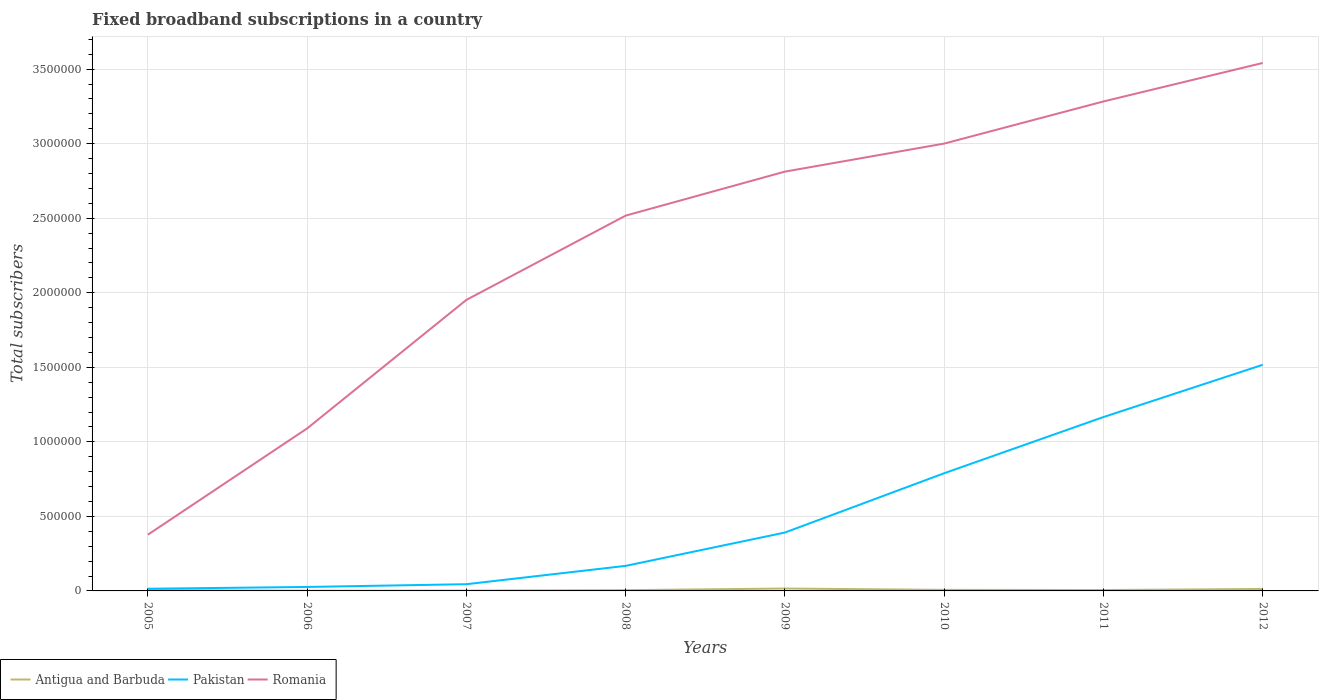Does the line corresponding to Pakistan intersect with the line corresponding to Antigua and Barbuda?
Keep it short and to the point. No. Across all years, what is the maximum number of broadband subscriptions in Antigua and Barbuda?
Your answer should be compact. 1541. In which year was the number of broadband subscriptions in Pakistan maximum?
Make the answer very short. 2005. What is the total number of broadband subscriptions in Pakistan in the graph?
Ensure brevity in your answer.  -1.53e+05. What is the difference between the highest and the second highest number of broadband subscriptions in Pakistan?
Provide a succinct answer. 1.50e+06. What is the difference between the highest and the lowest number of broadband subscriptions in Romania?
Provide a short and direct response. 5. Is the number of broadband subscriptions in Antigua and Barbuda strictly greater than the number of broadband subscriptions in Romania over the years?
Keep it short and to the point. Yes. How many years are there in the graph?
Offer a very short reply. 8. Does the graph contain any zero values?
Keep it short and to the point. No. Does the graph contain grids?
Give a very brief answer. Yes. How many legend labels are there?
Your answer should be compact. 3. What is the title of the graph?
Offer a terse response. Fixed broadband subscriptions in a country. What is the label or title of the X-axis?
Keep it short and to the point. Years. What is the label or title of the Y-axis?
Your answer should be compact. Total subscribers. What is the Total subscribers in Antigua and Barbuda in 2005?
Give a very brief answer. 5801. What is the Total subscribers in Pakistan in 2005?
Your answer should be compact. 1.46e+04. What is the Total subscribers of Romania in 2005?
Your answer should be compact. 3.77e+05. What is the Total subscribers in Antigua and Barbuda in 2006?
Your response must be concise. 1541. What is the Total subscribers of Pakistan in 2006?
Ensure brevity in your answer.  2.66e+04. What is the Total subscribers of Romania in 2006?
Offer a very short reply. 1.09e+06. What is the Total subscribers in Antigua and Barbuda in 2007?
Your response must be concise. 2266. What is the Total subscribers of Pakistan in 2007?
Keep it short and to the point. 4.52e+04. What is the Total subscribers in Romania in 2007?
Ensure brevity in your answer.  1.95e+06. What is the Total subscribers in Antigua and Barbuda in 2008?
Provide a succinct answer. 4986. What is the Total subscribers of Pakistan in 2008?
Make the answer very short. 1.68e+05. What is the Total subscribers in Romania in 2008?
Ensure brevity in your answer.  2.52e+06. What is the Total subscribers in Antigua and Barbuda in 2009?
Your answer should be very brief. 1.60e+04. What is the Total subscribers in Pakistan in 2009?
Provide a succinct answer. 3.92e+05. What is the Total subscribers of Romania in 2009?
Your answer should be compact. 2.81e+06. What is the Total subscribers in Antigua and Barbuda in 2010?
Provide a short and direct response. 7119. What is the Total subscribers of Pakistan in 2010?
Offer a terse response. 7.89e+05. What is the Total subscribers in Romania in 2010?
Provide a succinct answer. 3.00e+06. What is the Total subscribers in Antigua and Barbuda in 2011?
Offer a very short reply. 6000. What is the Total subscribers in Pakistan in 2011?
Ensure brevity in your answer.  1.17e+06. What is the Total subscribers in Romania in 2011?
Keep it short and to the point. 3.28e+06. What is the Total subscribers of Antigua and Barbuda in 2012?
Offer a terse response. 1.31e+04. What is the Total subscribers of Pakistan in 2012?
Give a very brief answer. 1.52e+06. What is the Total subscribers of Romania in 2012?
Offer a very short reply. 3.54e+06. Across all years, what is the maximum Total subscribers in Antigua and Barbuda?
Your answer should be compact. 1.60e+04. Across all years, what is the maximum Total subscribers in Pakistan?
Your answer should be very brief. 1.52e+06. Across all years, what is the maximum Total subscribers in Romania?
Make the answer very short. 3.54e+06. Across all years, what is the minimum Total subscribers in Antigua and Barbuda?
Ensure brevity in your answer.  1541. Across all years, what is the minimum Total subscribers of Pakistan?
Your response must be concise. 1.46e+04. Across all years, what is the minimum Total subscribers in Romania?
Offer a very short reply. 3.77e+05. What is the total Total subscribers of Antigua and Barbuda in the graph?
Offer a terse response. 5.68e+04. What is the total Total subscribers in Pakistan in the graph?
Your answer should be very brief. 4.12e+06. What is the total Total subscribers in Romania in the graph?
Ensure brevity in your answer.  1.86e+07. What is the difference between the Total subscribers in Antigua and Barbuda in 2005 and that in 2006?
Offer a terse response. 4260. What is the difference between the Total subscribers in Pakistan in 2005 and that in 2006?
Make the answer very short. -1.20e+04. What is the difference between the Total subscribers of Romania in 2005 and that in 2006?
Provide a short and direct response. -7.13e+05. What is the difference between the Total subscribers in Antigua and Barbuda in 2005 and that in 2007?
Your answer should be very brief. 3535. What is the difference between the Total subscribers of Pakistan in 2005 and that in 2007?
Offer a very short reply. -3.06e+04. What is the difference between the Total subscribers in Romania in 2005 and that in 2007?
Your response must be concise. -1.58e+06. What is the difference between the Total subscribers in Antigua and Barbuda in 2005 and that in 2008?
Your answer should be compact. 815. What is the difference between the Total subscribers in Pakistan in 2005 and that in 2008?
Your answer should be compact. -1.53e+05. What is the difference between the Total subscribers of Romania in 2005 and that in 2008?
Offer a very short reply. -2.14e+06. What is the difference between the Total subscribers in Antigua and Barbuda in 2005 and that in 2009?
Offer a very short reply. -1.02e+04. What is the difference between the Total subscribers of Pakistan in 2005 and that in 2009?
Make the answer very short. -3.77e+05. What is the difference between the Total subscribers in Romania in 2005 and that in 2009?
Keep it short and to the point. -2.44e+06. What is the difference between the Total subscribers in Antigua and Barbuda in 2005 and that in 2010?
Your answer should be very brief. -1318. What is the difference between the Total subscribers of Pakistan in 2005 and that in 2010?
Your answer should be very brief. -7.75e+05. What is the difference between the Total subscribers in Romania in 2005 and that in 2010?
Keep it short and to the point. -2.62e+06. What is the difference between the Total subscribers in Antigua and Barbuda in 2005 and that in 2011?
Provide a succinct answer. -199. What is the difference between the Total subscribers in Pakistan in 2005 and that in 2011?
Your answer should be very brief. -1.15e+06. What is the difference between the Total subscribers of Romania in 2005 and that in 2011?
Your answer should be very brief. -2.91e+06. What is the difference between the Total subscribers of Antigua and Barbuda in 2005 and that in 2012?
Ensure brevity in your answer.  -7269. What is the difference between the Total subscribers of Pakistan in 2005 and that in 2012?
Provide a succinct answer. -1.50e+06. What is the difference between the Total subscribers of Romania in 2005 and that in 2012?
Make the answer very short. -3.16e+06. What is the difference between the Total subscribers in Antigua and Barbuda in 2006 and that in 2007?
Make the answer very short. -725. What is the difference between the Total subscribers of Pakistan in 2006 and that in 2007?
Provide a succinct answer. -1.85e+04. What is the difference between the Total subscribers in Romania in 2006 and that in 2007?
Provide a succinct answer. -8.62e+05. What is the difference between the Total subscribers of Antigua and Barbuda in 2006 and that in 2008?
Give a very brief answer. -3445. What is the difference between the Total subscribers of Pakistan in 2006 and that in 2008?
Provide a short and direct response. -1.41e+05. What is the difference between the Total subscribers in Romania in 2006 and that in 2008?
Offer a very short reply. -1.43e+06. What is the difference between the Total subscribers of Antigua and Barbuda in 2006 and that in 2009?
Keep it short and to the point. -1.45e+04. What is the difference between the Total subscribers of Pakistan in 2006 and that in 2009?
Your answer should be compact. -3.65e+05. What is the difference between the Total subscribers in Romania in 2006 and that in 2009?
Keep it short and to the point. -1.72e+06. What is the difference between the Total subscribers in Antigua and Barbuda in 2006 and that in 2010?
Offer a very short reply. -5578. What is the difference between the Total subscribers in Pakistan in 2006 and that in 2010?
Make the answer very short. -7.63e+05. What is the difference between the Total subscribers of Romania in 2006 and that in 2010?
Give a very brief answer. -1.91e+06. What is the difference between the Total subscribers in Antigua and Barbuda in 2006 and that in 2011?
Your answer should be compact. -4459. What is the difference between the Total subscribers in Pakistan in 2006 and that in 2011?
Give a very brief answer. -1.14e+06. What is the difference between the Total subscribers in Romania in 2006 and that in 2011?
Make the answer very short. -2.19e+06. What is the difference between the Total subscribers in Antigua and Barbuda in 2006 and that in 2012?
Offer a very short reply. -1.15e+04. What is the difference between the Total subscribers of Pakistan in 2006 and that in 2012?
Offer a very short reply. -1.49e+06. What is the difference between the Total subscribers in Romania in 2006 and that in 2012?
Your answer should be compact. -2.45e+06. What is the difference between the Total subscribers in Antigua and Barbuda in 2007 and that in 2008?
Provide a succinct answer. -2720. What is the difference between the Total subscribers in Pakistan in 2007 and that in 2008?
Offer a terse response. -1.23e+05. What is the difference between the Total subscribers of Romania in 2007 and that in 2008?
Give a very brief answer. -5.65e+05. What is the difference between the Total subscribers in Antigua and Barbuda in 2007 and that in 2009?
Make the answer very short. -1.37e+04. What is the difference between the Total subscribers of Pakistan in 2007 and that in 2009?
Provide a succinct answer. -3.46e+05. What is the difference between the Total subscribers of Romania in 2007 and that in 2009?
Ensure brevity in your answer.  -8.60e+05. What is the difference between the Total subscribers in Antigua and Barbuda in 2007 and that in 2010?
Your answer should be very brief. -4853. What is the difference between the Total subscribers in Pakistan in 2007 and that in 2010?
Your answer should be compact. -7.44e+05. What is the difference between the Total subscribers in Romania in 2007 and that in 2010?
Provide a short and direct response. -1.05e+06. What is the difference between the Total subscribers of Antigua and Barbuda in 2007 and that in 2011?
Your response must be concise. -3734. What is the difference between the Total subscribers of Pakistan in 2007 and that in 2011?
Offer a terse response. -1.12e+06. What is the difference between the Total subscribers of Romania in 2007 and that in 2011?
Provide a succinct answer. -1.33e+06. What is the difference between the Total subscribers in Antigua and Barbuda in 2007 and that in 2012?
Your answer should be compact. -1.08e+04. What is the difference between the Total subscribers in Pakistan in 2007 and that in 2012?
Offer a very short reply. -1.47e+06. What is the difference between the Total subscribers of Romania in 2007 and that in 2012?
Offer a terse response. -1.59e+06. What is the difference between the Total subscribers of Antigua and Barbuda in 2008 and that in 2009?
Make the answer very short. -1.10e+04. What is the difference between the Total subscribers in Pakistan in 2008 and that in 2009?
Your response must be concise. -2.24e+05. What is the difference between the Total subscribers in Romania in 2008 and that in 2009?
Give a very brief answer. -2.95e+05. What is the difference between the Total subscribers in Antigua and Barbuda in 2008 and that in 2010?
Offer a terse response. -2133. What is the difference between the Total subscribers in Pakistan in 2008 and that in 2010?
Offer a terse response. -6.21e+05. What is the difference between the Total subscribers in Romania in 2008 and that in 2010?
Your response must be concise. -4.83e+05. What is the difference between the Total subscribers of Antigua and Barbuda in 2008 and that in 2011?
Your answer should be very brief. -1014. What is the difference between the Total subscribers of Pakistan in 2008 and that in 2011?
Give a very brief answer. -9.98e+05. What is the difference between the Total subscribers in Romania in 2008 and that in 2011?
Provide a succinct answer. -7.66e+05. What is the difference between the Total subscribers in Antigua and Barbuda in 2008 and that in 2012?
Provide a short and direct response. -8084. What is the difference between the Total subscribers of Pakistan in 2008 and that in 2012?
Give a very brief answer. -1.35e+06. What is the difference between the Total subscribers in Romania in 2008 and that in 2012?
Your response must be concise. -1.02e+06. What is the difference between the Total subscribers of Antigua and Barbuda in 2009 and that in 2010?
Provide a succinct answer. 8895. What is the difference between the Total subscribers of Pakistan in 2009 and that in 2010?
Offer a terse response. -3.98e+05. What is the difference between the Total subscribers of Romania in 2009 and that in 2010?
Make the answer very short. -1.88e+05. What is the difference between the Total subscribers of Antigua and Barbuda in 2009 and that in 2011?
Your response must be concise. 1.00e+04. What is the difference between the Total subscribers in Pakistan in 2009 and that in 2011?
Your response must be concise. -7.75e+05. What is the difference between the Total subscribers of Romania in 2009 and that in 2011?
Your answer should be very brief. -4.71e+05. What is the difference between the Total subscribers of Antigua and Barbuda in 2009 and that in 2012?
Offer a very short reply. 2944. What is the difference between the Total subscribers of Pakistan in 2009 and that in 2012?
Keep it short and to the point. -1.13e+06. What is the difference between the Total subscribers of Romania in 2009 and that in 2012?
Provide a short and direct response. -7.29e+05. What is the difference between the Total subscribers in Antigua and Barbuda in 2010 and that in 2011?
Your answer should be compact. 1119. What is the difference between the Total subscribers of Pakistan in 2010 and that in 2011?
Offer a terse response. -3.77e+05. What is the difference between the Total subscribers in Romania in 2010 and that in 2011?
Keep it short and to the point. -2.83e+05. What is the difference between the Total subscribers of Antigua and Barbuda in 2010 and that in 2012?
Your answer should be compact. -5951. What is the difference between the Total subscribers in Pakistan in 2010 and that in 2012?
Provide a short and direct response. -7.27e+05. What is the difference between the Total subscribers of Romania in 2010 and that in 2012?
Ensure brevity in your answer.  -5.41e+05. What is the difference between the Total subscribers in Antigua and Barbuda in 2011 and that in 2012?
Offer a terse response. -7070. What is the difference between the Total subscribers of Pakistan in 2011 and that in 2012?
Provide a succinct answer. -3.51e+05. What is the difference between the Total subscribers of Romania in 2011 and that in 2012?
Give a very brief answer. -2.58e+05. What is the difference between the Total subscribers of Antigua and Barbuda in 2005 and the Total subscribers of Pakistan in 2006?
Your answer should be compact. -2.08e+04. What is the difference between the Total subscribers of Antigua and Barbuda in 2005 and the Total subscribers of Romania in 2006?
Your answer should be very brief. -1.08e+06. What is the difference between the Total subscribers of Pakistan in 2005 and the Total subscribers of Romania in 2006?
Offer a very short reply. -1.08e+06. What is the difference between the Total subscribers in Antigua and Barbuda in 2005 and the Total subscribers in Pakistan in 2007?
Ensure brevity in your answer.  -3.94e+04. What is the difference between the Total subscribers in Antigua and Barbuda in 2005 and the Total subscribers in Romania in 2007?
Give a very brief answer. -1.95e+06. What is the difference between the Total subscribers of Pakistan in 2005 and the Total subscribers of Romania in 2007?
Your answer should be very brief. -1.94e+06. What is the difference between the Total subscribers in Antigua and Barbuda in 2005 and the Total subscribers in Pakistan in 2008?
Provide a short and direct response. -1.62e+05. What is the difference between the Total subscribers in Antigua and Barbuda in 2005 and the Total subscribers in Romania in 2008?
Give a very brief answer. -2.51e+06. What is the difference between the Total subscribers of Pakistan in 2005 and the Total subscribers of Romania in 2008?
Offer a very short reply. -2.50e+06. What is the difference between the Total subscribers of Antigua and Barbuda in 2005 and the Total subscribers of Pakistan in 2009?
Ensure brevity in your answer.  -3.86e+05. What is the difference between the Total subscribers in Antigua and Barbuda in 2005 and the Total subscribers in Romania in 2009?
Provide a short and direct response. -2.81e+06. What is the difference between the Total subscribers of Pakistan in 2005 and the Total subscribers of Romania in 2009?
Offer a terse response. -2.80e+06. What is the difference between the Total subscribers in Antigua and Barbuda in 2005 and the Total subscribers in Pakistan in 2010?
Keep it short and to the point. -7.84e+05. What is the difference between the Total subscribers in Antigua and Barbuda in 2005 and the Total subscribers in Romania in 2010?
Keep it short and to the point. -2.99e+06. What is the difference between the Total subscribers in Pakistan in 2005 and the Total subscribers in Romania in 2010?
Your answer should be very brief. -2.99e+06. What is the difference between the Total subscribers in Antigua and Barbuda in 2005 and the Total subscribers in Pakistan in 2011?
Offer a terse response. -1.16e+06. What is the difference between the Total subscribers of Antigua and Barbuda in 2005 and the Total subscribers of Romania in 2011?
Your answer should be compact. -3.28e+06. What is the difference between the Total subscribers in Pakistan in 2005 and the Total subscribers in Romania in 2011?
Your answer should be compact. -3.27e+06. What is the difference between the Total subscribers in Antigua and Barbuda in 2005 and the Total subscribers in Pakistan in 2012?
Provide a short and direct response. -1.51e+06. What is the difference between the Total subscribers of Antigua and Barbuda in 2005 and the Total subscribers of Romania in 2012?
Offer a terse response. -3.54e+06. What is the difference between the Total subscribers in Pakistan in 2005 and the Total subscribers in Romania in 2012?
Offer a terse response. -3.53e+06. What is the difference between the Total subscribers of Antigua and Barbuda in 2006 and the Total subscribers of Pakistan in 2007?
Your response must be concise. -4.36e+04. What is the difference between the Total subscribers in Antigua and Barbuda in 2006 and the Total subscribers in Romania in 2007?
Make the answer very short. -1.95e+06. What is the difference between the Total subscribers in Pakistan in 2006 and the Total subscribers in Romania in 2007?
Your answer should be very brief. -1.93e+06. What is the difference between the Total subscribers of Antigua and Barbuda in 2006 and the Total subscribers of Pakistan in 2008?
Your answer should be very brief. -1.67e+05. What is the difference between the Total subscribers of Antigua and Barbuda in 2006 and the Total subscribers of Romania in 2008?
Give a very brief answer. -2.52e+06. What is the difference between the Total subscribers in Pakistan in 2006 and the Total subscribers in Romania in 2008?
Provide a succinct answer. -2.49e+06. What is the difference between the Total subscribers of Antigua and Barbuda in 2006 and the Total subscribers of Pakistan in 2009?
Ensure brevity in your answer.  -3.90e+05. What is the difference between the Total subscribers of Antigua and Barbuda in 2006 and the Total subscribers of Romania in 2009?
Your answer should be very brief. -2.81e+06. What is the difference between the Total subscribers of Pakistan in 2006 and the Total subscribers of Romania in 2009?
Give a very brief answer. -2.79e+06. What is the difference between the Total subscribers of Antigua and Barbuda in 2006 and the Total subscribers of Pakistan in 2010?
Provide a succinct answer. -7.88e+05. What is the difference between the Total subscribers of Antigua and Barbuda in 2006 and the Total subscribers of Romania in 2010?
Give a very brief answer. -3.00e+06. What is the difference between the Total subscribers in Pakistan in 2006 and the Total subscribers in Romania in 2010?
Provide a short and direct response. -2.97e+06. What is the difference between the Total subscribers of Antigua and Barbuda in 2006 and the Total subscribers of Pakistan in 2011?
Provide a short and direct response. -1.16e+06. What is the difference between the Total subscribers in Antigua and Barbuda in 2006 and the Total subscribers in Romania in 2011?
Your answer should be compact. -3.28e+06. What is the difference between the Total subscribers of Pakistan in 2006 and the Total subscribers of Romania in 2011?
Your answer should be very brief. -3.26e+06. What is the difference between the Total subscribers of Antigua and Barbuda in 2006 and the Total subscribers of Pakistan in 2012?
Your answer should be compact. -1.52e+06. What is the difference between the Total subscribers in Antigua and Barbuda in 2006 and the Total subscribers in Romania in 2012?
Keep it short and to the point. -3.54e+06. What is the difference between the Total subscribers in Pakistan in 2006 and the Total subscribers in Romania in 2012?
Provide a succinct answer. -3.51e+06. What is the difference between the Total subscribers of Antigua and Barbuda in 2007 and the Total subscribers of Pakistan in 2008?
Provide a short and direct response. -1.66e+05. What is the difference between the Total subscribers in Antigua and Barbuda in 2007 and the Total subscribers in Romania in 2008?
Offer a terse response. -2.52e+06. What is the difference between the Total subscribers of Pakistan in 2007 and the Total subscribers of Romania in 2008?
Offer a very short reply. -2.47e+06. What is the difference between the Total subscribers of Antigua and Barbuda in 2007 and the Total subscribers of Pakistan in 2009?
Keep it short and to the point. -3.89e+05. What is the difference between the Total subscribers in Antigua and Barbuda in 2007 and the Total subscribers in Romania in 2009?
Your response must be concise. -2.81e+06. What is the difference between the Total subscribers of Pakistan in 2007 and the Total subscribers of Romania in 2009?
Give a very brief answer. -2.77e+06. What is the difference between the Total subscribers in Antigua and Barbuda in 2007 and the Total subscribers in Pakistan in 2010?
Keep it short and to the point. -7.87e+05. What is the difference between the Total subscribers of Antigua and Barbuda in 2007 and the Total subscribers of Romania in 2010?
Make the answer very short. -3.00e+06. What is the difference between the Total subscribers in Pakistan in 2007 and the Total subscribers in Romania in 2010?
Your answer should be compact. -2.96e+06. What is the difference between the Total subscribers in Antigua and Barbuda in 2007 and the Total subscribers in Pakistan in 2011?
Provide a succinct answer. -1.16e+06. What is the difference between the Total subscribers of Antigua and Barbuda in 2007 and the Total subscribers of Romania in 2011?
Keep it short and to the point. -3.28e+06. What is the difference between the Total subscribers in Pakistan in 2007 and the Total subscribers in Romania in 2011?
Provide a succinct answer. -3.24e+06. What is the difference between the Total subscribers in Antigua and Barbuda in 2007 and the Total subscribers in Pakistan in 2012?
Provide a short and direct response. -1.51e+06. What is the difference between the Total subscribers in Antigua and Barbuda in 2007 and the Total subscribers in Romania in 2012?
Keep it short and to the point. -3.54e+06. What is the difference between the Total subscribers of Pakistan in 2007 and the Total subscribers of Romania in 2012?
Your response must be concise. -3.50e+06. What is the difference between the Total subscribers in Antigua and Barbuda in 2008 and the Total subscribers in Pakistan in 2009?
Give a very brief answer. -3.87e+05. What is the difference between the Total subscribers in Antigua and Barbuda in 2008 and the Total subscribers in Romania in 2009?
Ensure brevity in your answer.  -2.81e+06. What is the difference between the Total subscribers of Pakistan in 2008 and the Total subscribers of Romania in 2009?
Offer a very short reply. -2.64e+06. What is the difference between the Total subscribers of Antigua and Barbuda in 2008 and the Total subscribers of Pakistan in 2010?
Your response must be concise. -7.85e+05. What is the difference between the Total subscribers in Antigua and Barbuda in 2008 and the Total subscribers in Romania in 2010?
Your answer should be very brief. -3.00e+06. What is the difference between the Total subscribers in Pakistan in 2008 and the Total subscribers in Romania in 2010?
Ensure brevity in your answer.  -2.83e+06. What is the difference between the Total subscribers in Antigua and Barbuda in 2008 and the Total subscribers in Pakistan in 2011?
Offer a terse response. -1.16e+06. What is the difference between the Total subscribers in Antigua and Barbuda in 2008 and the Total subscribers in Romania in 2011?
Offer a terse response. -3.28e+06. What is the difference between the Total subscribers of Pakistan in 2008 and the Total subscribers of Romania in 2011?
Make the answer very short. -3.12e+06. What is the difference between the Total subscribers in Antigua and Barbuda in 2008 and the Total subscribers in Pakistan in 2012?
Your response must be concise. -1.51e+06. What is the difference between the Total subscribers in Antigua and Barbuda in 2008 and the Total subscribers in Romania in 2012?
Offer a terse response. -3.54e+06. What is the difference between the Total subscribers in Pakistan in 2008 and the Total subscribers in Romania in 2012?
Your answer should be compact. -3.37e+06. What is the difference between the Total subscribers in Antigua and Barbuda in 2009 and the Total subscribers in Pakistan in 2010?
Your answer should be compact. -7.73e+05. What is the difference between the Total subscribers of Antigua and Barbuda in 2009 and the Total subscribers of Romania in 2010?
Provide a succinct answer. -2.98e+06. What is the difference between the Total subscribers of Pakistan in 2009 and the Total subscribers of Romania in 2010?
Give a very brief answer. -2.61e+06. What is the difference between the Total subscribers in Antigua and Barbuda in 2009 and the Total subscribers in Pakistan in 2011?
Offer a very short reply. -1.15e+06. What is the difference between the Total subscribers of Antigua and Barbuda in 2009 and the Total subscribers of Romania in 2011?
Provide a short and direct response. -3.27e+06. What is the difference between the Total subscribers in Pakistan in 2009 and the Total subscribers in Romania in 2011?
Your answer should be compact. -2.89e+06. What is the difference between the Total subscribers of Antigua and Barbuda in 2009 and the Total subscribers of Pakistan in 2012?
Your response must be concise. -1.50e+06. What is the difference between the Total subscribers of Antigua and Barbuda in 2009 and the Total subscribers of Romania in 2012?
Your response must be concise. -3.53e+06. What is the difference between the Total subscribers in Pakistan in 2009 and the Total subscribers in Romania in 2012?
Your answer should be compact. -3.15e+06. What is the difference between the Total subscribers of Antigua and Barbuda in 2010 and the Total subscribers of Pakistan in 2011?
Your answer should be compact. -1.16e+06. What is the difference between the Total subscribers in Antigua and Barbuda in 2010 and the Total subscribers in Romania in 2011?
Provide a succinct answer. -3.28e+06. What is the difference between the Total subscribers in Pakistan in 2010 and the Total subscribers in Romania in 2011?
Your response must be concise. -2.49e+06. What is the difference between the Total subscribers of Antigua and Barbuda in 2010 and the Total subscribers of Pakistan in 2012?
Provide a succinct answer. -1.51e+06. What is the difference between the Total subscribers in Antigua and Barbuda in 2010 and the Total subscribers in Romania in 2012?
Give a very brief answer. -3.53e+06. What is the difference between the Total subscribers of Pakistan in 2010 and the Total subscribers of Romania in 2012?
Provide a succinct answer. -2.75e+06. What is the difference between the Total subscribers of Antigua and Barbuda in 2011 and the Total subscribers of Pakistan in 2012?
Your answer should be very brief. -1.51e+06. What is the difference between the Total subscribers of Antigua and Barbuda in 2011 and the Total subscribers of Romania in 2012?
Keep it short and to the point. -3.54e+06. What is the difference between the Total subscribers in Pakistan in 2011 and the Total subscribers in Romania in 2012?
Your answer should be compact. -2.38e+06. What is the average Total subscribers in Antigua and Barbuda per year?
Provide a short and direct response. 7099.62. What is the average Total subscribers in Pakistan per year?
Give a very brief answer. 5.15e+05. What is the average Total subscribers in Romania per year?
Give a very brief answer. 2.32e+06. In the year 2005, what is the difference between the Total subscribers in Antigua and Barbuda and Total subscribers in Pakistan?
Provide a succinct answer. -8799. In the year 2005, what is the difference between the Total subscribers of Antigua and Barbuda and Total subscribers of Romania?
Provide a succinct answer. -3.71e+05. In the year 2005, what is the difference between the Total subscribers of Pakistan and Total subscribers of Romania?
Ensure brevity in your answer.  -3.62e+05. In the year 2006, what is the difference between the Total subscribers in Antigua and Barbuda and Total subscribers in Pakistan?
Your answer should be compact. -2.51e+04. In the year 2006, what is the difference between the Total subscribers of Antigua and Barbuda and Total subscribers of Romania?
Make the answer very short. -1.09e+06. In the year 2006, what is the difference between the Total subscribers in Pakistan and Total subscribers in Romania?
Make the answer very short. -1.06e+06. In the year 2007, what is the difference between the Total subscribers in Antigua and Barbuda and Total subscribers in Pakistan?
Offer a very short reply. -4.29e+04. In the year 2007, what is the difference between the Total subscribers of Antigua and Barbuda and Total subscribers of Romania?
Keep it short and to the point. -1.95e+06. In the year 2007, what is the difference between the Total subscribers of Pakistan and Total subscribers of Romania?
Offer a very short reply. -1.91e+06. In the year 2008, what is the difference between the Total subscribers of Antigua and Barbuda and Total subscribers of Pakistan?
Ensure brevity in your answer.  -1.63e+05. In the year 2008, what is the difference between the Total subscribers in Antigua and Barbuda and Total subscribers in Romania?
Your answer should be very brief. -2.51e+06. In the year 2008, what is the difference between the Total subscribers of Pakistan and Total subscribers of Romania?
Offer a very short reply. -2.35e+06. In the year 2009, what is the difference between the Total subscribers of Antigua and Barbuda and Total subscribers of Pakistan?
Your response must be concise. -3.76e+05. In the year 2009, what is the difference between the Total subscribers of Antigua and Barbuda and Total subscribers of Romania?
Give a very brief answer. -2.80e+06. In the year 2009, what is the difference between the Total subscribers of Pakistan and Total subscribers of Romania?
Provide a short and direct response. -2.42e+06. In the year 2010, what is the difference between the Total subscribers in Antigua and Barbuda and Total subscribers in Pakistan?
Make the answer very short. -7.82e+05. In the year 2010, what is the difference between the Total subscribers in Antigua and Barbuda and Total subscribers in Romania?
Ensure brevity in your answer.  -2.99e+06. In the year 2010, what is the difference between the Total subscribers of Pakistan and Total subscribers of Romania?
Provide a succinct answer. -2.21e+06. In the year 2011, what is the difference between the Total subscribers in Antigua and Barbuda and Total subscribers in Pakistan?
Offer a terse response. -1.16e+06. In the year 2011, what is the difference between the Total subscribers of Antigua and Barbuda and Total subscribers of Romania?
Offer a very short reply. -3.28e+06. In the year 2011, what is the difference between the Total subscribers of Pakistan and Total subscribers of Romania?
Keep it short and to the point. -2.12e+06. In the year 2012, what is the difference between the Total subscribers of Antigua and Barbuda and Total subscribers of Pakistan?
Make the answer very short. -1.50e+06. In the year 2012, what is the difference between the Total subscribers of Antigua and Barbuda and Total subscribers of Romania?
Your response must be concise. -3.53e+06. In the year 2012, what is the difference between the Total subscribers of Pakistan and Total subscribers of Romania?
Your answer should be compact. -2.02e+06. What is the ratio of the Total subscribers of Antigua and Barbuda in 2005 to that in 2006?
Give a very brief answer. 3.76. What is the ratio of the Total subscribers in Pakistan in 2005 to that in 2006?
Your answer should be compact. 0.55. What is the ratio of the Total subscribers in Romania in 2005 to that in 2006?
Make the answer very short. 0.35. What is the ratio of the Total subscribers of Antigua and Barbuda in 2005 to that in 2007?
Provide a succinct answer. 2.56. What is the ratio of the Total subscribers in Pakistan in 2005 to that in 2007?
Ensure brevity in your answer.  0.32. What is the ratio of the Total subscribers in Romania in 2005 to that in 2007?
Give a very brief answer. 0.19. What is the ratio of the Total subscribers in Antigua and Barbuda in 2005 to that in 2008?
Your answer should be very brief. 1.16. What is the ratio of the Total subscribers of Pakistan in 2005 to that in 2008?
Offer a terse response. 0.09. What is the ratio of the Total subscribers in Romania in 2005 to that in 2008?
Ensure brevity in your answer.  0.15. What is the ratio of the Total subscribers in Antigua and Barbuda in 2005 to that in 2009?
Keep it short and to the point. 0.36. What is the ratio of the Total subscribers in Pakistan in 2005 to that in 2009?
Provide a short and direct response. 0.04. What is the ratio of the Total subscribers in Romania in 2005 to that in 2009?
Your answer should be compact. 0.13. What is the ratio of the Total subscribers in Antigua and Barbuda in 2005 to that in 2010?
Keep it short and to the point. 0.81. What is the ratio of the Total subscribers of Pakistan in 2005 to that in 2010?
Your answer should be very brief. 0.02. What is the ratio of the Total subscribers in Romania in 2005 to that in 2010?
Provide a succinct answer. 0.13. What is the ratio of the Total subscribers of Antigua and Barbuda in 2005 to that in 2011?
Provide a short and direct response. 0.97. What is the ratio of the Total subscribers of Pakistan in 2005 to that in 2011?
Ensure brevity in your answer.  0.01. What is the ratio of the Total subscribers in Romania in 2005 to that in 2011?
Keep it short and to the point. 0.11. What is the ratio of the Total subscribers in Antigua and Barbuda in 2005 to that in 2012?
Your response must be concise. 0.44. What is the ratio of the Total subscribers of Pakistan in 2005 to that in 2012?
Make the answer very short. 0.01. What is the ratio of the Total subscribers in Romania in 2005 to that in 2012?
Make the answer very short. 0.11. What is the ratio of the Total subscribers in Antigua and Barbuda in 2006 to that in 2007?
Make the answer very short. 0.68. What is the ratio of the Total subscribers in Pakistan in 2006 to that in 2007?
Your answer should be compact. 0.59. What is the ratio of the Total subscribers in Romania in 2006 to that in 2007?
Provide a succinct answer. 0.56. What is the ratio of the Total subscribers in Antigua and Barbuda in 2006 to that in 2008?
Your answer should be very brief. 0.31. What is the ratio of the Total subscribers in Pakistan in 2006 to that in 2008?
Provide a succinct answer. 0.16. What is the ratio of the Total subscribers of Romania in 2006 to that in 2008?
Provide a short and direct response. 0.43. What is the ratio of the Total subscribers in Antigua and Barbuda in 2006 to that in 2009?
Keep it short and to the point. 0.1. What is the ratio of the Total subscribers in Pakistan in 2006 to that in 2009?
Your response must be concise. 0.07. What is the ratio of the Total subscribers in Romania in 2006 to that in 2009?
Make the answer very short. 0.39. What is the ratio of the Total subscribers in Antigua and Barbuda in 2006 to that in 2010?
Ensure brevity in your answer.  0.22. What is the ratio of the Total subscribers in Pakistan in 2006 to that in 2010?
Provide a short and direct response. 0.03. What is the ratio of the Total subscribers of Romania in 2006 to that in 2010?
Your response must be concise. 0.36. What is the ratio of the Total subscribers of Antigua and Barbuda in 2006 to that in 2011?
Keep it short and to the point. 0.26. What is the ratio of the Total subscribers of Pakistan in 2006 to that in 2011?
Your answer should be compact. 0.02. What is the ratio of the Total subscribers in Romania in 2006 to that in 2011?
Provide a succinct answer. 0.33. What is the ratio of the Total subscribers in Antigua and Barbuda in 2006 to that in 2012?
Your answer should be very brief. 0.12. What is the ratio of the Total subscribers of Pakistan in 2006 to that in 2012?
Provide a succinct answer. 0.02. What is the ratio of the Total subscribers in Romania in 2006 to that in 2012?
Your answer should be very brief. 0.31. What is the ratio of the Total subscribers in Antigua and Barbuda in 2007 to that in 2008?
Give a very brief answer. 0.45. What is the ratio of the Total subscribers of Pakistan in 2007 to that in 2008?
Offer a terse response. 0.27. What is the ratio of the Total subscribers of Romania in 2007 to that in 2008?
Offer a terse response. 0.78. What is the ratio of the Total subscribers in Antigua and Barbuda in 2007 to that in 2009?
Give a very brief answer. 0.14. What is the ratio of the Total subscribers of Pakistan in 2007 to that in 2009?
Provide a short and direct response. 0.12. What is the ratio of the Total subscribers in Romania in 2007 to that in 2009?
Provide a succinct answer. 0.69. What is the ratio of the Total subscribers of Antigua and Barbuda in 2007 to that in 2010?
Make the answer very short. 0.32. What is the ratio of the Total subscribers in Pakistan in 2007 to that in 2010?
Your answer should be compact. 0.06. What is the ratio of the Total subscribers of Romania in 2007 to that in 2010?
Ensure brevity in your answer.  0.65. What is the ratio of the Total subscribers in Antigua and Barbuda in 2007 to that in 2011?
Offer a very short reply. 0.38. What is the ratio of the Total subscribers in Pakistan in 2007 to that in 2011?
Keep it short and to the point. 0.04. What is the ratio of the Total subscribers of Romania in 2007 to that in 2011?
Give a very brief answer. 0.59. What is the ratio of the Total subscribers of Antigua and Barbuda in 2007 to that in 2012?
Provide a succinct answer. 0.17. What is the ratio of the Total subscribers of Pakistan in 2007 to that in 2012?
Offer a very short reply. 0.03. What is the ratio of the Total subscribers in Romania in 2007 to that in 2012?
Give a very brief answer. 0.55. What is the ratio of the Total subscribers in Antigua and Barbuda in 2008 to that in 2009?
Your response must be concise. 0.31. What is the ratio of the Total subscribers in Pakistan in 2008 to that in 2009?
Ensure brevity in your answer.  0.43. What is the ratio of the Total subscribers of Romania in 2008 to that in 2009?
Keep it short and to the point. 0.9. What is the ratio of the Total subscribers in Antigua and Barbuda in 2008 to that in 2010?
Offer a terse response. 0.7. What is the ratio of the Total subscribers of Pakistan in 2008 to that in 2010?
Your answer should be very brief. 0.21. What is the ratio of the Total subscribers in Romania in 2008 to that in 2010?
Offer a very short reply. 0.84. What is the ratio of the Total subscribers of Antigua and Barbuda in 2008 to that in 2011?
Your response must be concise. 0.83. What is the ratio of the Total subscribers in Pakistan in 2008 to that in 2011?
Offer a very short reply. 0.14. What is the ratio of the Total subscribers of Romania in 2008 to that in 2011?
Ensure brevity in your answer.  0.77. What is the ratio of the Total subscribers of Antigua and Barbuda in 2008 to that in 2012?
Make the answer very short. 0.38. What is the ratio of the Total subscribers in Pakistan in 2008 to that in 2012?
Ensure brevity in your answer.  0.11. What is the ratio of the Total subscribers in Romania in 2008 to that in 2012?
Your answer should be very brief. 0.71. What is the ratio of the Total subscribers in Antigua and Barbuda in 2009 to that in 2010?
Ensure brevity in your answer.  2.25. What is the ratio of the Total subscribers of Pakistan in 2009 to that in 2010?
Provide a succinct answer. 0.5. What is the ratio of the Total subscribers of Romania in 2009 to that in 2010?
Provide a succinct answer. 0.94. What is the ratio of the Total subscribers of Antigua and Barbuda in 2009 to that in 2011?
Make the answer very short. 2.67. What is the ratio of the Total subscribers of Pakistan in 2009 to that in 2011?
Your response must be concise. 0.34. What is the ratio of the Total subscribers in Romania in 2009 to that in 2011?
Provide a short and direct response. 0.86. What is the ratio of the Total subscribers in Antigua and Barbuda in 2009 to that in 2012?
Provide a succinct answer. 1.23. What is the ratio of the Total subscribers in Pakistan in 2009 to that in 2012?
Provide a short and direct response. 0.26. What is the ratio of the Total subscribers of Romania in 2009 to that in 2012?
Ensure brevity in your answer.  0.79. What is the ratio of the Total subscribers of Antigua and Barbuda in 2010 to that in 2011?
Offer a terse response. 1.19. What is the ratio of the Total subscribers of Pakistan in 2010 to that in 2011?
Your answer should be very brief. 0.68. What is the ratio of the Total subscribers of Romania in 2010 to that in 2011?
Keep it short and to the point. 0.91. What is the ratio of the Total subscribers of Antigua and Barbuda in 2010 to that in 2012?
Your response must be concise. 0.54. What is the ratio of the Total subscribers in Pakistan in 2010 to that in 2012?
Provide a short and direct response. 0.52. What is the ratio of the Total subscribers of Romania in 2010 to that in 2012?
Offer a terse response. 0.85. What is the ratio of the Total subscribers in Antigua and Barbuda in 2011 to that in 2012?
Give a very brief answer. 0.46. What is the ratio of the Total subscribers of Pakistan in 2011 to that in 2012?
Your answer should be very brief. 0.77. What is the ratio of the Total subscribers in Romania in 2011 to that in 2012?
Provide a succinct answer. 0.93. What is the difference between the highest and the second highest Total subscribers of Antigua and Barbuda?
Offer a very short reply. 2944. What is the difference between the highest and the second highest Total subscribers of Pakistan?
Keep it short and to the point. 3.51e+05. What is the difference between the highest and the second highest Total subscribers in Romania?
Your answer should be compact. 2.58e+05. What is the difference between the highest and the lowest Total subscribers of Antigua and Barbuda?
Your answer should be very brief. 1.45e+04. What is the difference between the highest and the lowest Total subscribers in Pakistan?
Provide a succinct answer. 1.50e+06. What is the difference between the highest and the lowest Total subscribers of Romania?
Offer a terse response. 3.16e+06. 